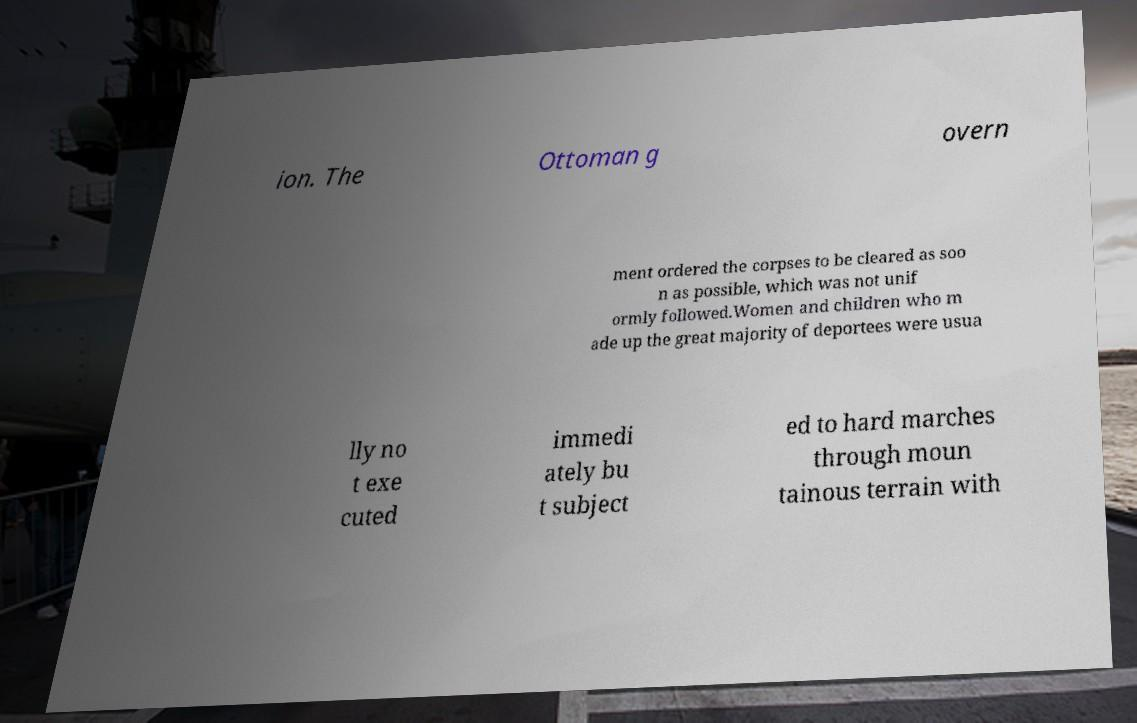Could you extract and type out the text from this image? ion. The Ottoman g overn ment ordered the corpses to be cleared as soo n as possible, which was not unif ormly followed.Women and children who m ade up the great majority of deportees were usua lly no t exe cuted immedi ately bu t subject ed to hard marches through moun tainous terrain with 